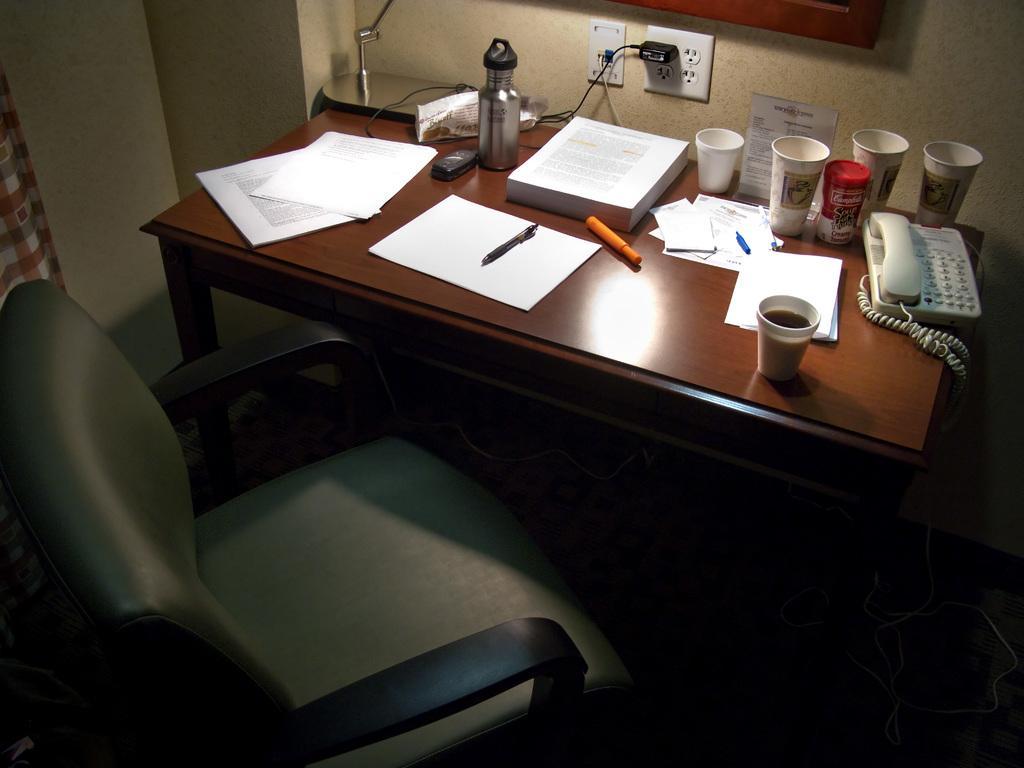Describe this image in one or two sentences. There is a green color chair. In front of the chair there is a table. On the table there are papers, pen, cups, glass, telephone, a bottle, to the top there is a lamp. And to the wall there are sockets. 